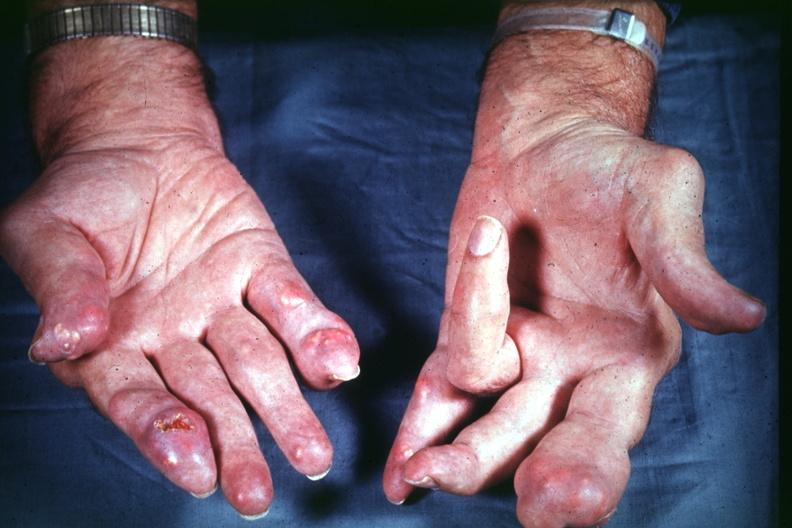s cachexia present?
Answer the question using a single word or phrase. No 